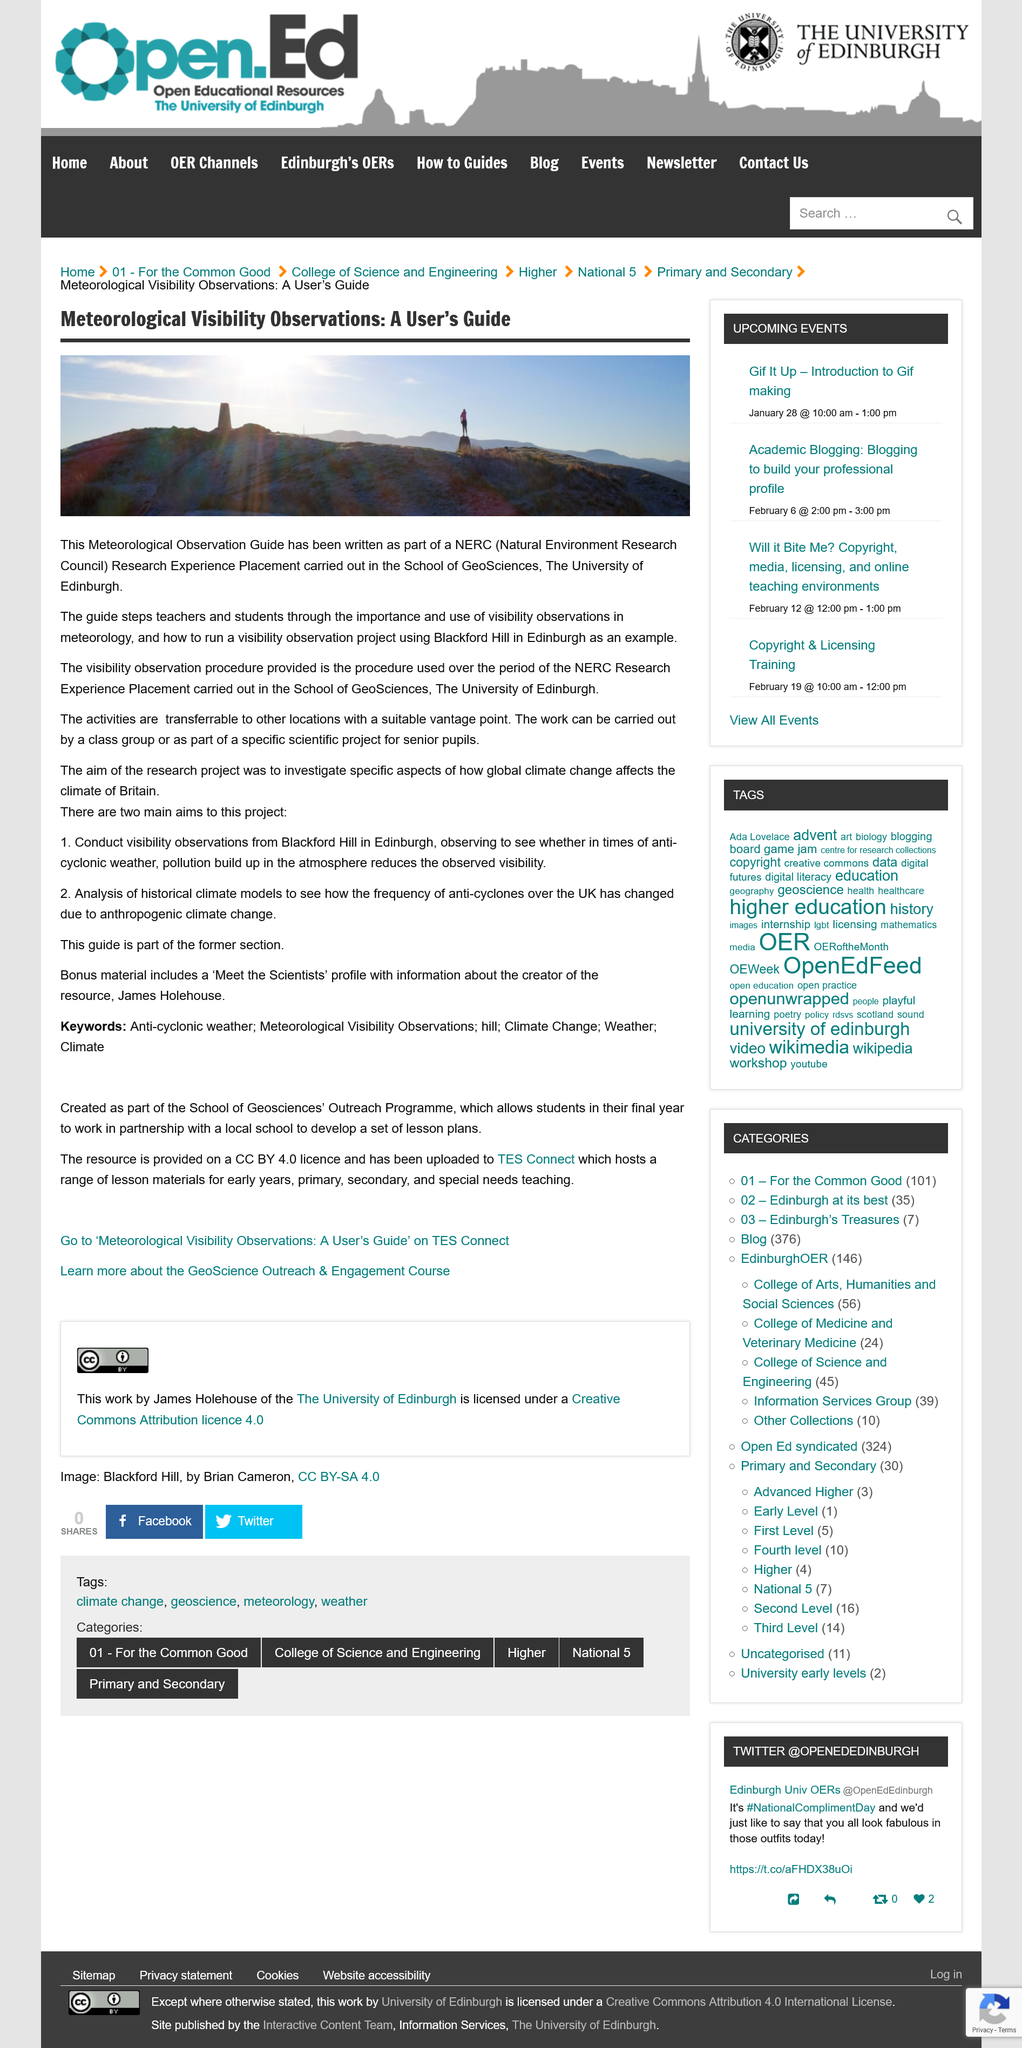List a handful of essential elements in this visual. The acronym "NERC" stands for "Natural Environment Research Council," which is a research organization dedicated to studying the natural environment and its resources. The research project aimed to investigate various aspects of global climate change. The University of Edinburgh's School of GeoSciences is located at the University of Edinburgh. 